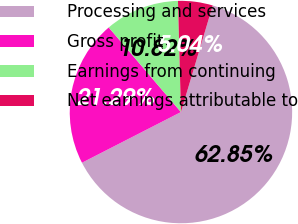Convert chart. <chart><loc_0><loc_0><loc_500><loc_500><pie_chart><fcel>Processing and services<fcel>Gross profit<fcel>Earnings from continuing<fcel>Net earnings attributable to<nl><fcel>62.86%<fcel>21.29%<fcel>10.82%<fcel>5.04%<nl></chart> 